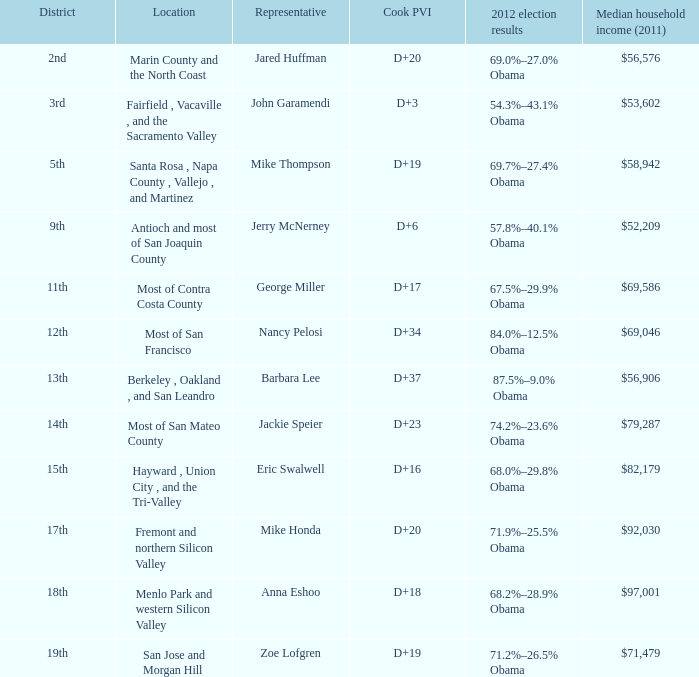What is the 2012 election results for locations whose representative is Barbara Lee? 87.5%–9.0% Obama. 